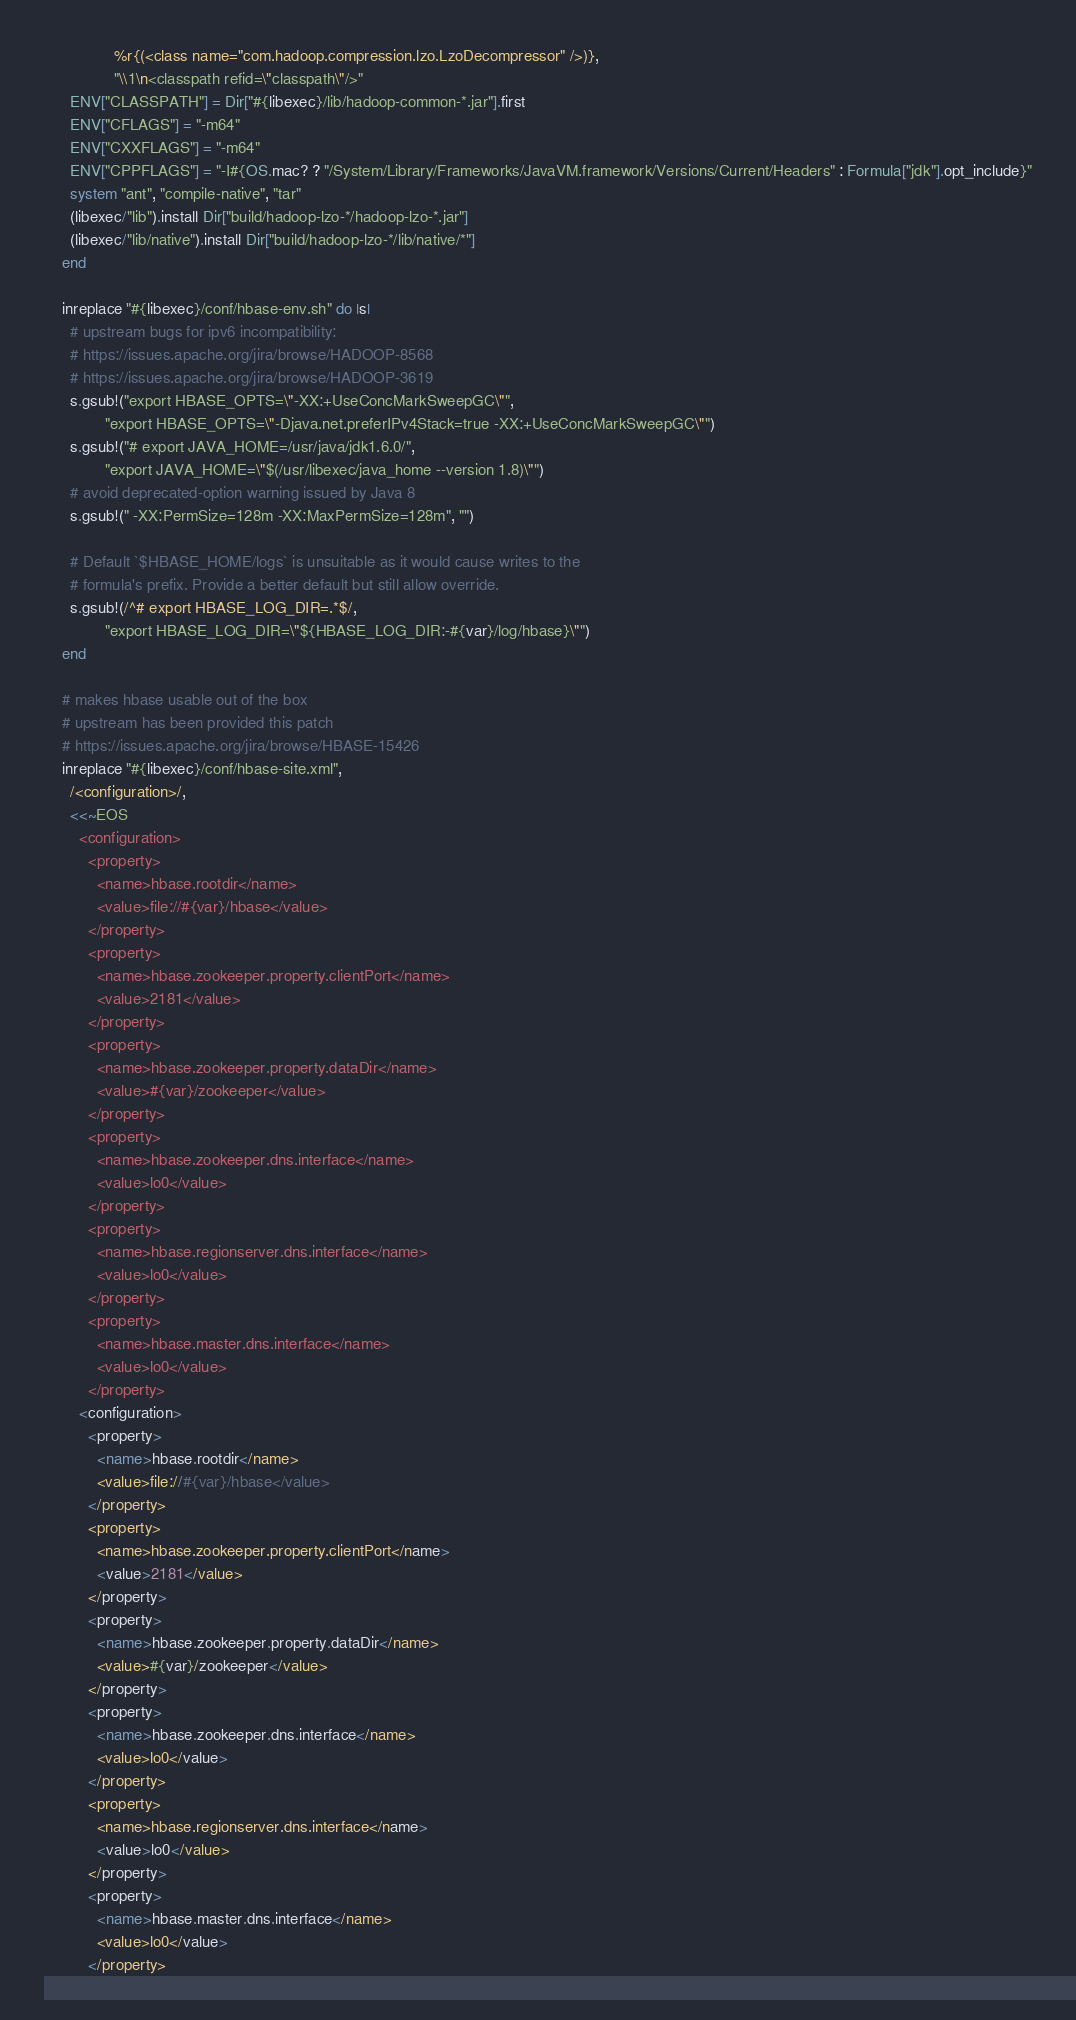Convert code to text. <code><loc_0><loc_0><loc_500><loc_500><_Ruby_>                %r{(<class name="com.hadoop.compression.lzo.LzoDecompressor" />)},
                "\\1\n<classpath refid=\"classpath\"/>"
      ENV["CLASSPATH"] = Dir["#{libexec}/lib/hadoop-common-*.jar"].first
      ENV["CFLAGS"] = "-m64"
      ENV["CXXFLAGS"] = "-m64"
      ENV["CPPFLAGS"] = "-I#{OS.mac? ? "/System/Library/Frameworks/JavaVM.framework/Versions/Current/Headers" : Formula["jdk"].opt_include}"
      system "ant", "compile-native", "tar"
      (libexec/"lib").install Dir["build/hadoop-lzo-*/hadoop-lzo-*.jar"]
      (libexec/"lib/native").install Dir["build/hadoop-lzo-*/lib/native/*"]
    end

    inreplace "#{libexec}/conf/hbase-env.sh" do |s|
      # upstream bugs for ipv6 incompatibility:
      # https://issues.apache.org/jira/browse/HADOOP-8568
      # https://issues.apache.org/jira/browse/HADOOP-3619
      s.gsub!("export HBASE_OPTS=\"-XX:+UseConcMarkSweepGC\"",
              "export HBASE_OPTS=\"-Djava.net.preferIPv4Stack=true -XX:+UseConcMarkSweepGC\"")
      s.gsub!("# export JAVA_HOME=/usr/java/jdk1.6.0/",
              "export JAVA_HOME=\"$(/usr/libexec/java_home --version 1.8)\"")
      # avoid deprecated-option warning issued by Java 8
      s.gsub!(" -XX:PermSize=128m -XX:MaxPermSize=128m", "")

      # Default `$HBASE_HOME/logs` is unsuitable as it would cause writes to the
      # formula's prefix. Provide a better default but still allow override.
      s.gsub!(/^# export HBASE_LOG_DIR=.*$/,
              "export HBASE_LOG_DIR=\"${HBASE_LOG_DIR:-#{var}/log/hbase}\"")
    end

    # makes hbase usable out of the box
    # upstream has been provided this patch
    # https://issues.apache.org/jira/browse/HBASE-15426
    inreplace "#{libexec}/conf/hbase-site.xml",
      /<configuration>/,
      <<~EOS
        <configuration>
          <property>
            <name>hbase.rootdir</name>
            <value>file://#{var}/hbase</value>
          </property>
          <property>
            <name>hbase.zookeeper.property.clientPort</name>
            <value>2181</value>
          </property>
          <property>
            <name>hbase.zookeeper.property.dataDir</name>
            <value>#{var}/zookeeper</value>
          </property>
          <property>
            <name>hbase.zookeeper.dns.interface</name>
            <value>lo0</value>
          </property>
          <property>
            <name>hbase.regionserver.dns.interface</name>
            <value>lo0</value>
          </property>
          <property>
            <name>hbase.master.dns.interface</name>
            <value>lo0</value>
          </property></code> 